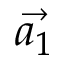Convert formula to latex. <formula><loc_0><loc_0><loc_500><loc_500>\vec { a _ { 1 } }</formula> 